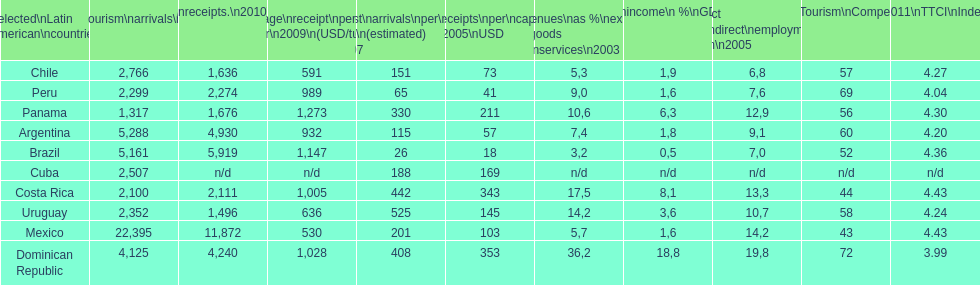What country had the least arrivals per 1000 inhabitants in 2007(estimated)? Brazil. 